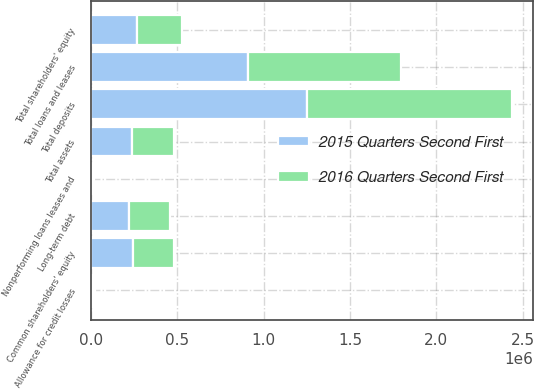<chart> <loc_0><loc_0><loc_500><loc_500><stacked_bar_chart><ecel><fcel>Total loans and leases<fcel>Total assets<fcel>Total deposits<fcel>Long-term debt<fcel>Common shareholders' equity<fcel>Total shareholders' equity<fcel>Allowance for credit losses<fcel>Nonperforming loans leases and<nl><fcel>2015 Quarters Second First<fcel>908396<fcel>241262<fcel>1.25095e+06<fcel>220587<fcel>245139<fcel>270360<fcel>11999<fcel>8084<nl><fcel>2016 Quarters Second First<fcel>886156<fcel>241262<fcel>1.18605e+06<fcel>237384<fcel>234800<fcel>257074<fcel>12880<fcel>9836<nl></chart> 